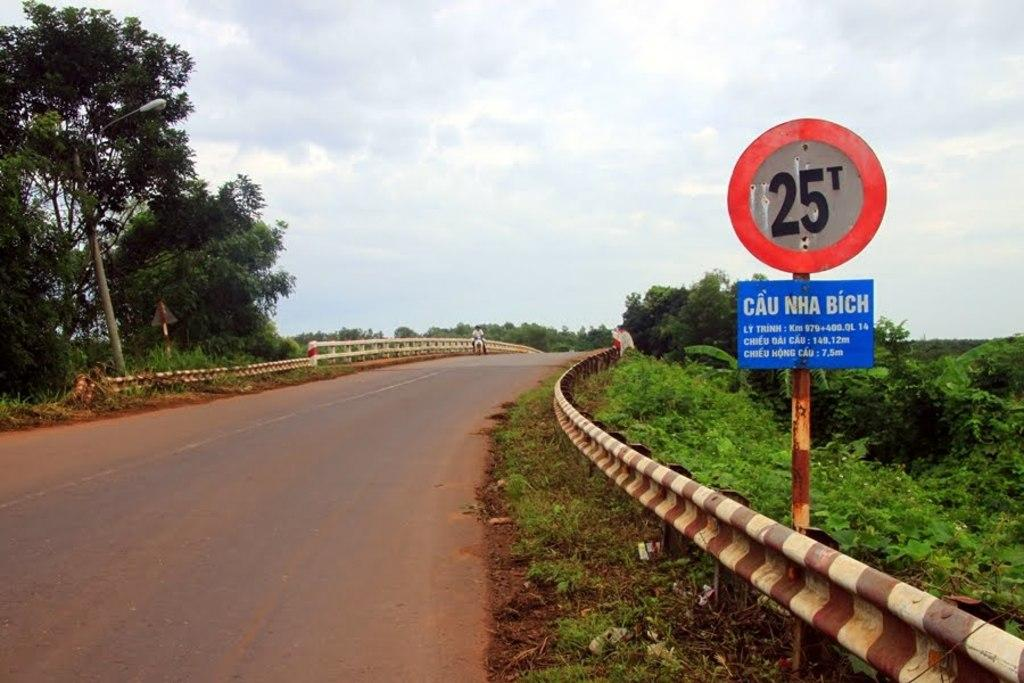Provide a one-sentence caption for the provided image. 25t Sign that says CAU NHA BICH on the side of the road. 